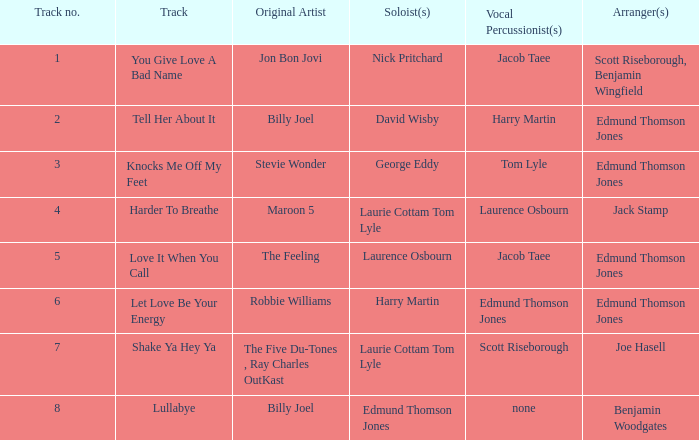How many compositions possess the title let love be your energy? 1.0. 